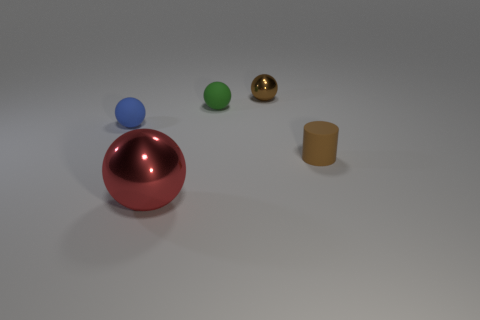Add 1 tiny blue things. How many objects exist? 6 Subtract all spheres. How many objects are left? 1 Subtract all metal spheres. Subtract all blue things. How many objects are left? 2 Add 1 big red balls. How many big red balls are left? 2 Add 3 tiny blue rubber objects. How many tiny blue rubber objects exist? 4 Subtract 1 brown spheres. How many objects are left? 4 